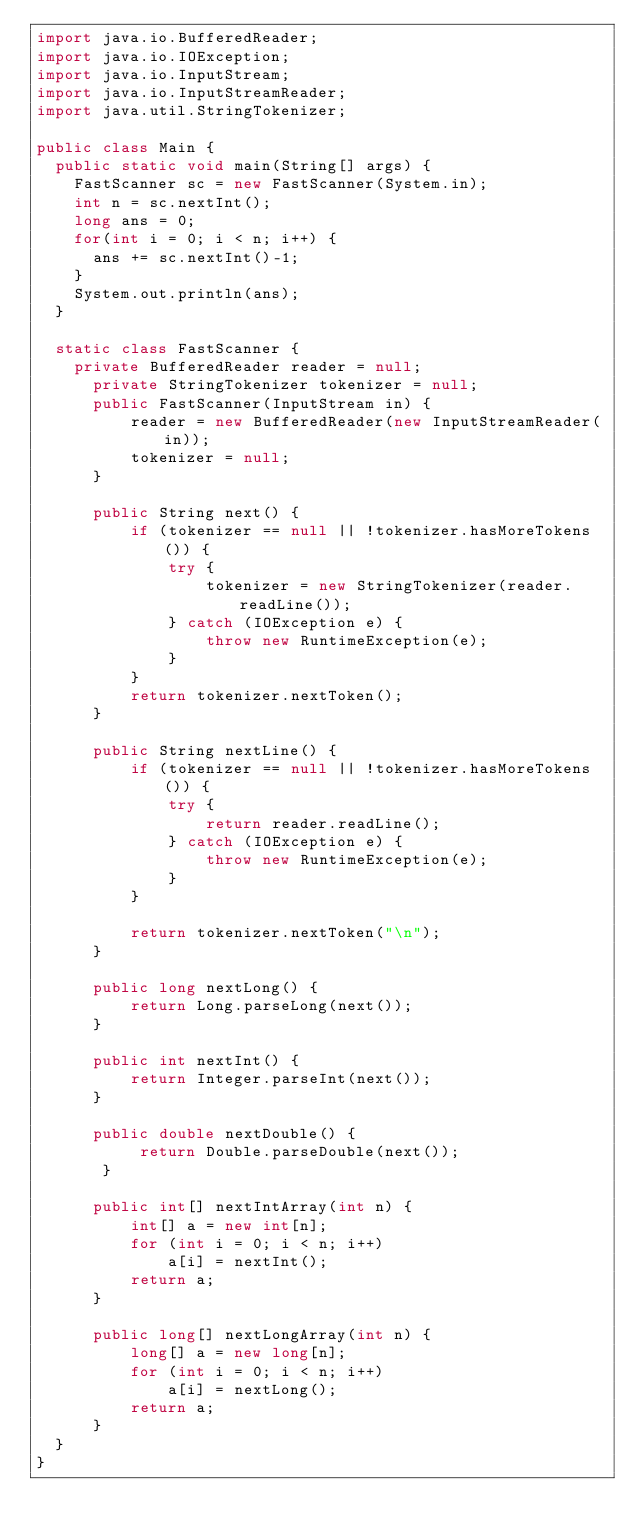Convert code to text. <code><loc_0><loc_0><loc_500><loc_500><_Java_>import java.io.BufferedReader;
import java.io.IOException;
import java.io.InputStream;
import java.io.InputStreamReader;
import java.util.StringTokenizer;

public class Main {
	public static void main(String[] args) {
		FastScanner sc = new FastScanner(System.in);
		int n = sc.nextInt();
		long ans = 0;
		for(int i = 0; i < n; i++) {
			ans += sc.nextInt()-1;
		}
		System.out.println(ans);
	}
	
	static class FastScanner {
		private BufferedReader reader = null;
	    private StringTokenizer tokenizer = null;
	    public FastScanner(InputStream in) {
	        reader = new BufferedReader(new InputStreamReader(in));
	        tokenizer = null;
	    }

	    public String next() {
	        if (tokenizer == null || !tokenizer.hasMoreTokens()) {
	            try {
	                tokenizer = new StringTokenizer(reader.readLine());
	            } catch (IOException e) {
	                throw new RuntimeException(e);
	            }
	        }
	        return tokenizer.nextToken();
	    }

	    public String nextLine() {
	        if (tokenizer == null || !tokenizer.hasMoreTokens()) {
	            try {
	                return reader.readLine();
	            } catch (IOException e) {
	                throw new RuntimeException(e);
	            }
	        }

	        return tokenizer.nextToken("\n");
	    }

	    public long nextLong() {
	        return Long.parseLong(next());
	    }

	    public int nextInt() {
	        return Integer.parseInt(next());
	    }

	    public double nextDouble() {
	         return Double.parseDouble(next());
	     }

	    public int[] nextIntArray(int n) {
	        int[] a = new int[n];
	        for (int i = 0; i < n; i++)
	            a[i] = nextInt();
	        return a;
	    }

	    public long[] nextLongArray(int n) {
	        long[] a = new long[n];
	        for (int i = 0; i < n; i++)
	            a[i] = nextLong();
	        return a;
	    }
	}
}
</code> 